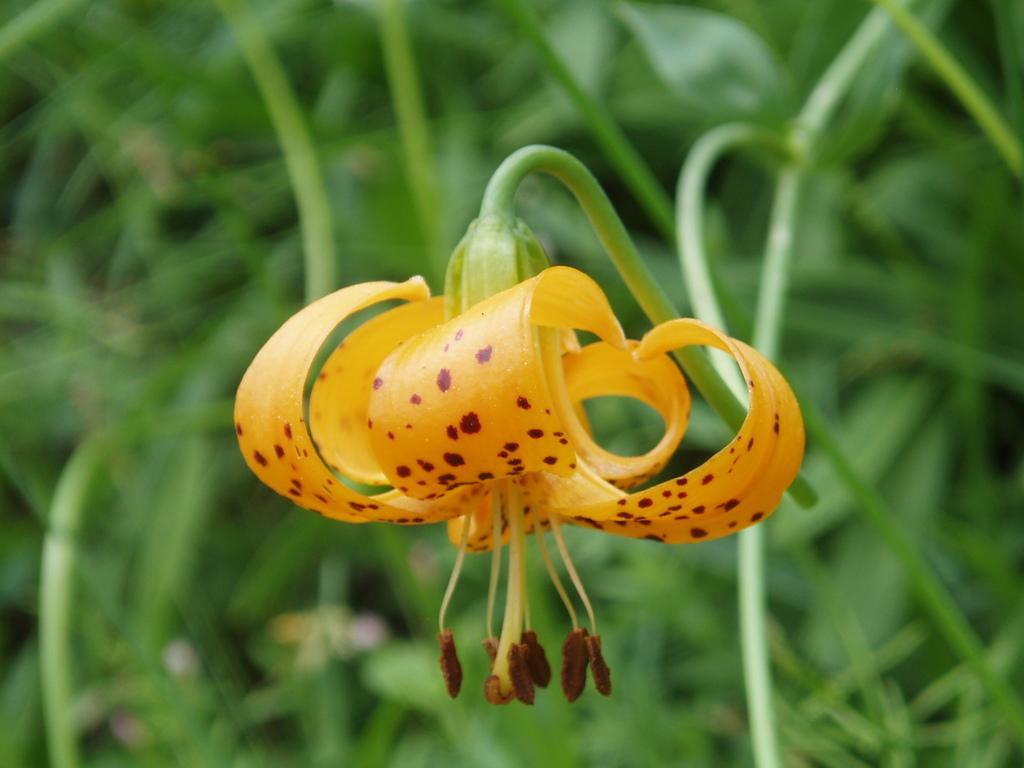Please provide a concise description of this image. In this image we can see a flower which is in yellow color and in the background of the image there are some leaves. 